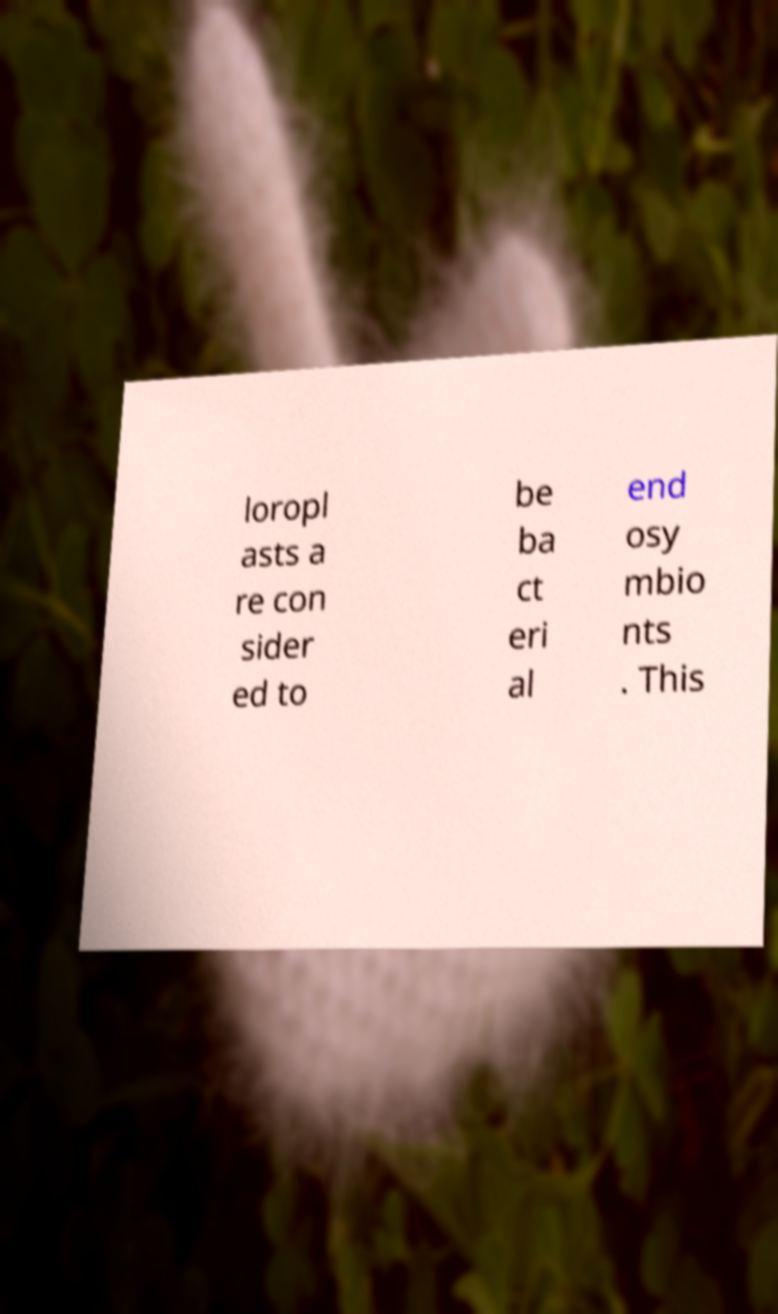Please identify and transcribe the text found in this image. loropl asts a re con sider ed to be ba ct eri al end osy mbio nts . This 